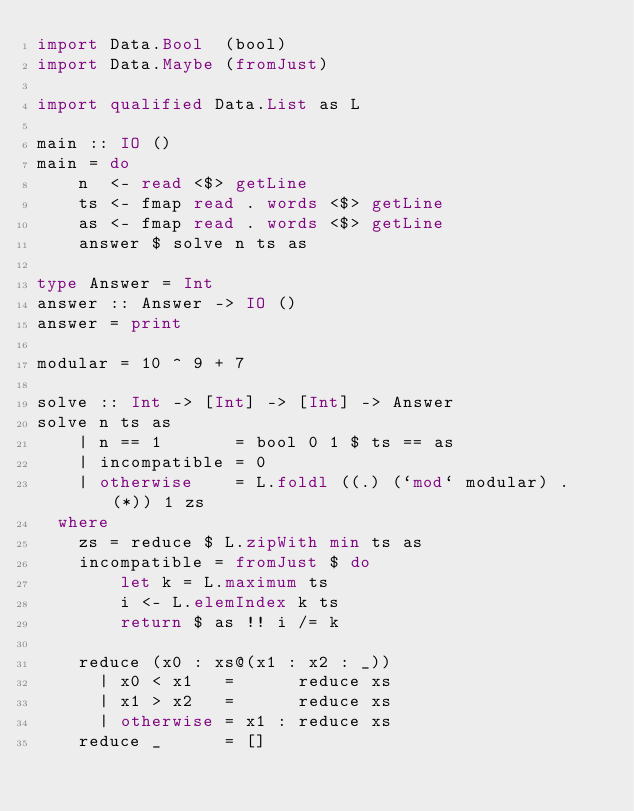<code> <loc_0><loc_0><loc_500><loc_500><_Haskell_>import Data.Bool  (bool)
import Data.Maybe (fromJust)

import qualified Data.List as L

main :: IO ()
main = do
    n  <- read <$> getLine
    ts <- fmap read . words <$> getLine
    as <- fmap read . words <$> getLine
    answer $ solve n ts as

type Answer = Int
answer :: Answer -> IO ()
answer = print

modular = 10 ^ 9 + 7

solve :: Int -> [Int] -> [Int] -> Answer
solve n ts as
    | n == 1       = bool 0 1 $ ts == as
    | incompatible = 0
    | otherwise    = L.foldl ((.) (`mod` modular) . (*)) 1 zs
  where
    zs = reduce $ L.zipWith min ts as
    incompatible = fromJust $ do
        let k = L.maximum ts
        i <- L.elemIndex k ts
        return $ as !! i /= k

    reduce (x0 : xs@(x1 : x2 : _))
      | x0 < x1   =      reduce xs
      | x1 > x2   =      reduce xs
      | otherwise = x1 : reduce xs
    reduce _      = []
</code> 